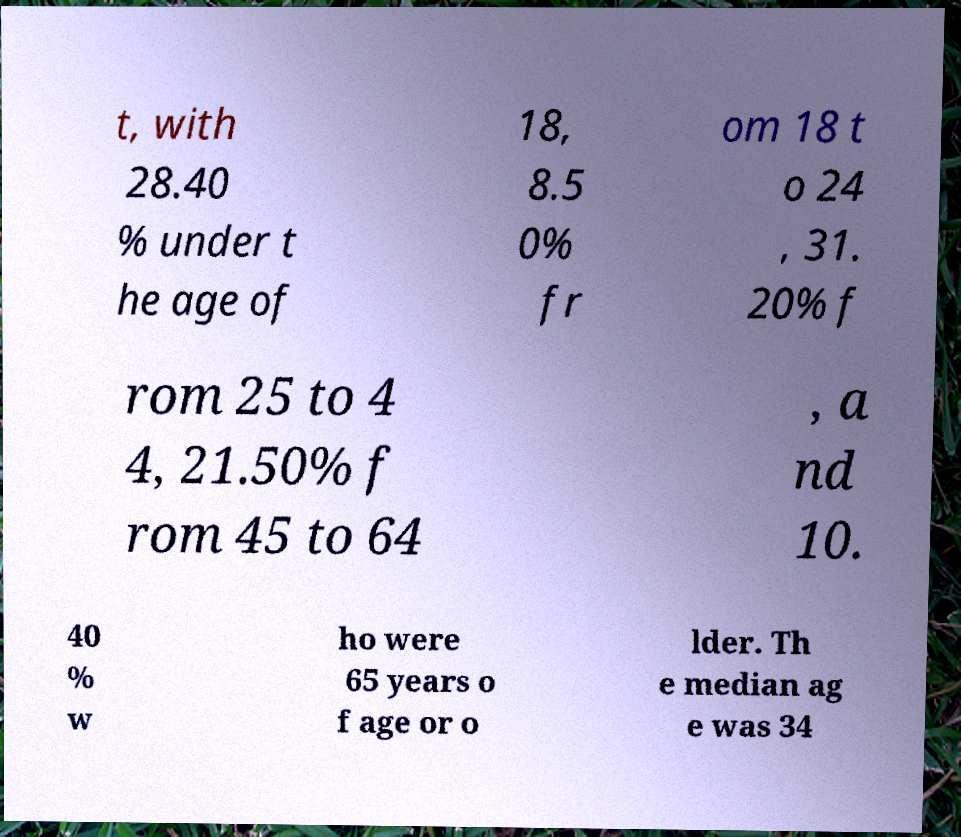Please identify and transcribe the text found in this image. t, with 28.40 % under t he age of 18, 8.5 0% fr om 18 t o 24 , 31. 20% f rom 25 to 4 4, 21.50% f rom 45 to 64 , a nd 10. 40 % w ho were 65 years o f age or o lder. Th e median ag e was 34 